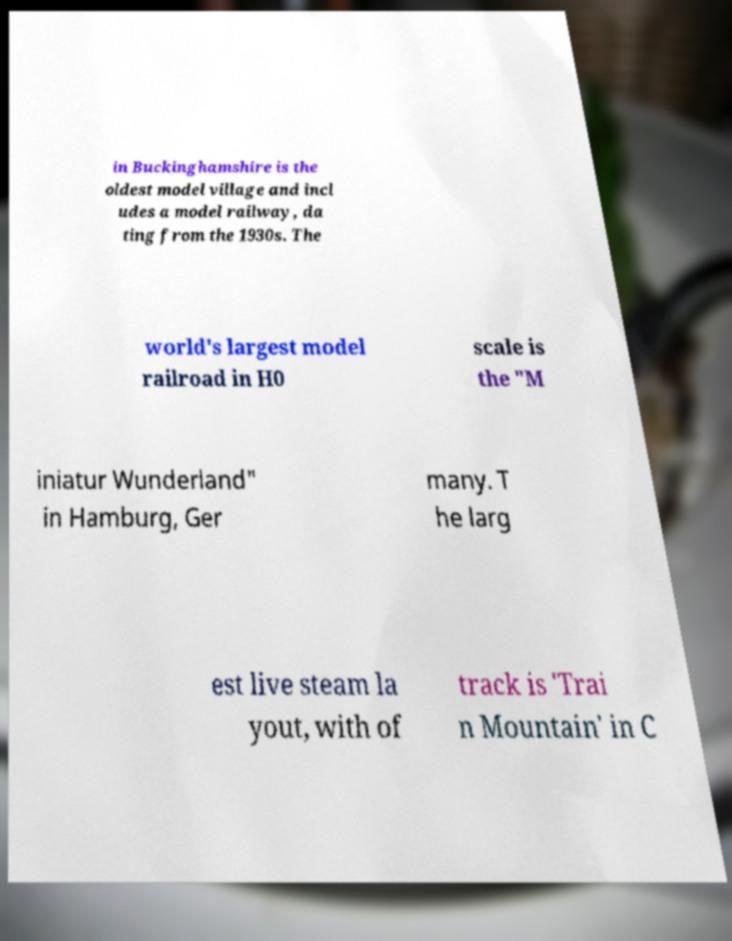I need the written content from this picture converted into text. Can you do that? in Buckinghamshire is the oldest model village and incl udes a model railway, da ting from the 1930s. The world's largest model railroad in H0 scale is the "M iniatur Wunderland" in Hamburg, Ger many. T he larg est live steam la yout, with of track is 'Trai n Mountain' in C 